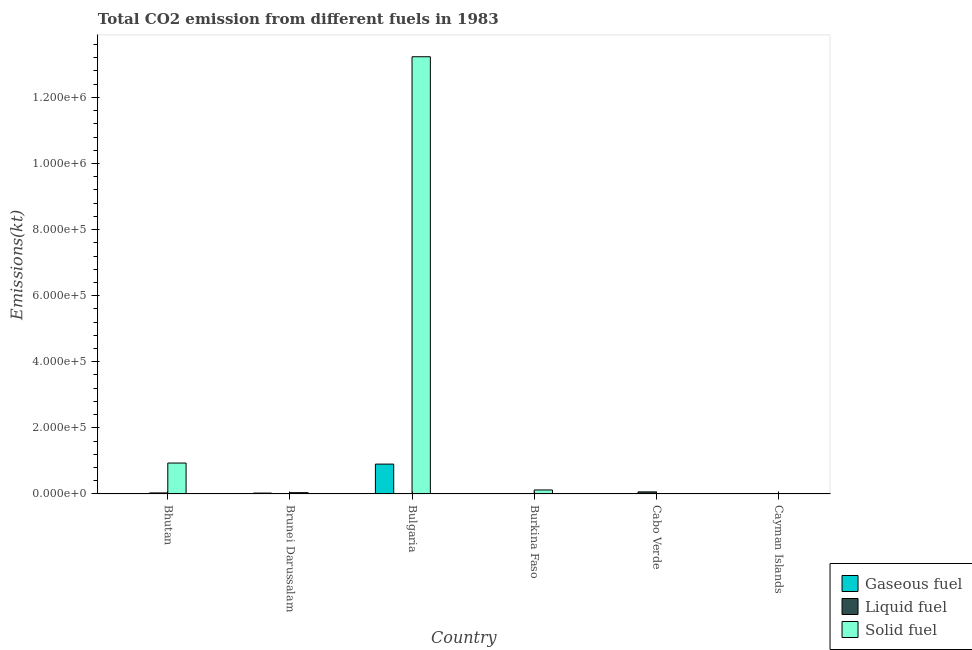How many different coloured bars are there?
Your answer should be compact. 3. Are the number of bars per tick equal to the number of legend labels?
Offer a very short reply. Yes. Are the number of bars on each tick of the X-axis equal?
Make the answer very short. Yes. How many bars are there on the 2nd tick from the left?
Ensure brevity in your answer.  3. What is the label of the 6th group of bars from the left?
Offer a terse response. Cayman Islands. In how many cases, is the number of bars for a given country not equal to the number of legend labels?
Make the answer very short. 0. What is the amount of co2 emissions from gaseous fuel in Burkina Faso?
Your response must be concise. 594.05. Across all countries, what is the maximum amount of co2 emissions from gaseous fuel?
Provide a short and direct response. 9.04e+04. Across all countries, what is the minimum amount of co2 emissions from solid fuel?
Provide a succinct answer. 238.35. In which country was the amount of co2 emissions from solid fuel maximum?
Keep it short and to the point. Bulgaria. In which country was the amount of co2 emissions from liquid fuel minimum?
Your answer should be very brief. Burkina Faso. What is the total amount of co2 emissions from solid fuel in the graph?
Make the answer very short. 1.43e+06. What is the difference between the amount of co2 emissions from solid fuel in Brunei Darussalam and that in Cabo Verde?
Ensure brevity in your answer.  3237.96. What is the difference between the amount of co2 emissions from solid fuel in Cayman Islands and the amount of co2 emissions from liquid fuel in Bulgaria?
Provide a succinct answer. 51.34. What is the average amount of co2 emissions from liquid fuel per country?
Provide a short and direct response. 1745.49. What is the difference between the amount of co2 emissions from gaseous fuel and amount of co2 emissions from liquid fuel in Bulgaria?
Provide a succinct answer. 9.02e+04. In how many countries, is the amount of co2 emissions from liquid fuel greater than 640000 kt?
Keep it short and to the point. 0. What is the ratio of the amount of co2 emissions from liquid fuel in Bhutan to that in Brunei Darussalam?
Give a very brief answer. 5.33. What is the difference between the highest and the second highest amount of co2 emissions from liquid fuel?
Give a very brief answer. 3113.28. What is the difference between the highest and the lowest amount of co2 emissions from liquid fuel?
Provide a succinct answer. 6244.9. Is the sum of the amount of co2 emissions from gaseous fuel in Cabo Verde and Cayman Islands greater than the maximum amount of co2 emissions from liquid fuel across all countries?
Provide a short and direct response. No. What does the 3rd bar from the left in Bulgaria represents?
Keep it short and to the point. Solid fuel. What does the 2nd bar from the right in Burkina Faso represents?
Make the answer very short. Liquid fuel. Is it the case that in every country, the sum of the amount of co2 emissions from gaseous fuel and amount of co2 emissions from liquid fuel is greater than the amount of co2 emissions from solid fuel?
Your answer should be compact. No. Are all the bars in the graph horizontal?
Keep it short and to the point. No. How many countries are there in the graph?
Make the answer very short. 6. What is the difference between two consecutive major ticks on the Y-axis?
Offer a terse response. 2.00e+05. Are the values on the major ticks of Y-axis written in scientific E-notation?
Offer a terse response. Yes. Does the graph contain any zero values?
Keep it short and to the point. No. Does the graph contain grids?
Offer a terse response. No. Where does the legend appear in the graph?
Your answer should be compact. Bottom right. What is the title of the graph?
Your response must be concise. Total CO2 emission from different fuels in 1983. What is the label or title of the X-axis?
Your response must be concise. Country. What is the label or title of the Y-axis?
Provide a short and direct response. Emissions(kt). What is the Emissions(kt) of Gaseous fuel in Bhutan?
Ensure brevity in your answer.  29.34. What is the Emissions(kt) of Liquid fuel in Bhutan?
Your answer should be very brief. 3168.29. What is the Emissions(kt) in Solid fuel in Bhutan?
Ensure brevity in your answer.  9.36e+04. What is the Emissions(kt) in Gaseous fuel in Brunei Darussalam?
Ensure brevity in your answer.  2706.25. What is the Emissions(kt) in Liquid fuel in Brunei Darussalam?
Provide a short and direct response. 594.05. What is the Emissions(kt) in Solid fuel in Brunei Darussalam?
Your answer should be very brief. 4044.7. What is the Emissions(kt) in Gaseous fuel in Bulgaria?
Offer a terse response. 9.04e+04. What is the Emissions(kt) of Liquid fuel in Bulgaria?
Your response must be concise. 187.02. What is the Emissions(kt) of Solid fuel in Bulgaria?
Offer a very short reply. 1.32e+06. What is the Emissions(kt) of Gaseous fuel in Burkina Faso?
Give a very brief answer. 594.05. What is the Emissions(kt) in Liquid fuel in Burkina Faso?
Give a very brief answer. 36.67. What is the Emissions(kt) of Solid fuel in Burkina Faso?
Your answer should be very brief. 1.21e+04. What is the Emissions(kt) of Gaseous fuel in Cabo Verde?
Your answer should be compact. 36.67. What is the Emissions(kt) in Liquid fuel in Cabo Verde?
Your answer should be compact. 6281.57. What is the Emissions(kt) in Solid fuel in Cabo Verde?
Provide a succinct answer. 806.74. What is the Emissions(kt) in Gaseous fuel in Cayman Islands?
Your response must be concise. 172.35. What is the Emissions(kt) in Liquid fuel in Cayman Islands?
Offer a very short reply. 205.35. What is the Emissions(kt) of Solid fuel in Cayman Islands?
Your answer should be compact. 238.35. Across all countries, what is the maximum Emissions(kt) in Gaseous fuel?
Ensure brevity in your answer.  9.04e+04. Across all countries, what is the maximum Emissions(kt) in Liquid fuel?
Your answer should be compact. 6281.57. Across all countries, what is the maximum Emissions(kt) in Solid fuel?
Provide a short and direct response. 1.32e+06. Across all countries, what is the minimum Emissions(kt) of Gaseous fuel?
Your answer should be compact. 29.34. Across all countries, what is the minimum Emissions(kt) of Liquid fuel?
Offer a very short reply. 36.67. Across all countries, what is the minimum Emissions(kt) in Solid fuel?
Ensure brevity in your answer.  238.35. What is the total Emissions(kt) in Gaseous fuel in the graph?
Offer a terse response. 9.39e+04. What is the total Emissions(kt) of Liquid fuel in the graph?
Provide a short and direct response. 1.05e+04. What is the total Emissions(kt) of Solid fuel in the graph?
Your answer should be compact. 1.43e+06. What is the difference between the Emissions(kt) in Gaseous fuel in Bhutan and that in Brunei Darussalam?
Ensure brevity in your answer.  -2676.91. What is the difference between the Emissions(kt) in Liquid fuel in Bhutan and that in Brunei Darussalam?
Your response must be concise. 2574.23. What is the difference between the Emissions(kt) in Solid fuel in Bhutan and that in Brunei Darussalam?
Give a very brief answer. 8.96e+04. What is the difference between the Emissions(kt) of Gaseous fuel in Bhutan and that in Bulgaria?
Provide a succinct answer. -9.03e+04. What is the difference between the Emissions(kt) in Liquid fuel in Bhutan and that in Bulgaria?
Offer a very short reply. 2981.27. What is the difference between the Emissions(kt) in Solid fuel in Bhutan and that in Bulgaria?
Provide a succinct answer. -1.23e+06. What is the difference between the Emissions(kt) in Gaseous fuel in Bhutan and that in Burkina Faso?
Make the answer very short. -564.72. What is the difference between the Emissions(kt) of Liquid fuel in Bhutan and that in Burkina Faso?
Your answer should be compact. 3131.62. What is the difference between the Emissions(kt) in Solid fuel in Bhutan and that in Burkina Faso?
Offer a terse response. 8.15e+04. What is the difference between the Emissions(kt) in Gaseous fuel in Bhutan and that in Cabo Verde?
Provide a short and direct response. -7.33. What is the difference between the Emissions(kt) in Liquid fuel in Bhutan and that in Cabo Verde?
Your answer should be very brief. -3113.28. What is the difference between the Emissions(kt) of Solid fuel in Bhutan and that in Cabo Verde?
Make the answer very short. 9.28e+04. What is the difference between the Emissions(kt) of Gaseous fuel in Bhutan and that in Cayman Islands?
Provide a succinct answer. -143.01. What is the difference between the Emissions(kt) of Liquid fuel in Bhutan and that in Cayman Islands?
Provide a short and direct response. 2962.94. What is the difference between the Emissions(kt) in Solid fuel in Bhutan and that in Cayman Islands?
Give a very brief answer. 9.34e+04. What is the difference between the Emissions(kt) in Gaseous fuel in Brunei Darussalam and that in Bulgaria?
Offer a very short reply. -8.77e+04. What is the difference between the Emissions(kt) in Liquid fuel in Brunei Darussalam and that in Bulgaria?
Give a very brief answer. 407.04. What is the difference between the Emissions(kt) of Solid fuel in Brunei Darussalam and that in Bulgaria?
Keep it short and to the point. -1.32e+06. What is the difference between the Emissions(kt) of Gaseous fuel in Brunei Darussalam and that in Burkina Faso?
Offer a terse response. 2112.19. What is the difference between the Emissions(kt) in Liquid fuel in Brunei Darussalam and that in Burkina Faso?
Offer a terse response. 557.38. What is the difference between the Emissions(kt) of Solid fuel in Brunei Darussalam and that in Burkina Faso?
Make the answer very short. -8104.07. What is the difference between the Emissions(kt) of Gaseous fuel in Brunei Darussalam and that in Cabo Verde?
Your answer should be very brief. 2669.58. What is the difference between the Emissions(kt) in Liquid fuel in Brunei Darussalam and that in Cabo Verde?
Your response must be concise. -5687.52. What is the difference between the Emissions(kt) in Solid fuel in Brunei Darussalam and that in Cabo Verde?
Keep it short and to the point. 3237.96. What is the difference between the Emissions(kt) of Gaseous fuel in Brunei Darussalam and that in Cayman Islands?
Your answer should be very brief. 2533.9. What is the difference between the Emissions(kt) of Liquid fuel in Brunei Darussalam and that in Cayman Islands?
Offer a terse response. 388.7. What is the difference between the Emissions(kt) in Solid fuel in Brunei Darussalam and that in Cayman Islands?
Your response must be concise. 3806.35. What is the difference between the Emissions(kt) of Gaseous fuel in Bulgaria and that in Burkina Faso?
Ensure brevity in your answer.  8.98e+04. What is the difference between the Emissions(kt) in Liquid fuel in Bulgaria and that in Burkina Faso?
Provide a succinct answer. 150.35. What is the difference between the Emissions(kt) of Solid fuel in Bulgaria and that in Burkina Faso?
Keep it short and to the point. 1.31e+06. What is the difference between the Emissions(kt) of Gaseous fuel in Bulgaria and that in Cabo Verde?
Ensure brevity in your answer.  9.03e+04. What is the difference between the Emissions(kt) of Liquid fuel in Bulgaria and that in Cabo Verde?
Offer a very short reply. -6094.55. What is the difference between the Emissions(kt) of Solid fuel in Bulgaria and that in Cabo Verde?
Offer a terse response. 1.32e+06. What is the difference between the Emissions(kt) of Gaseous fuel in Bulgaria and that in Cayman Islands?
Your answer should be very brief. 9.02e+04. What is the difference between the Emissions(kt) of Liquid fuel in Bulgaria and that in Cayman Islands?
Your response must be concise. -18.34. What is the difference between the Emissions(kt) of Solid fuel in Bulgaria and that in Cayman Islands?
Offer a terse response. 1.32e+06. What is the difference between the Emissions(kt) in Gaseous fuel in Burkina Faso and that in Cabo Verde?
Provide a succinct answer. 557.38. What is the difference between the Emissions(kt) in Liquid fuel in Burkina Faso and that in Cabo Verde?
Your response must be concise. -6244.9. What is the difference between the Emissions(kt) in Solid fuel in Burkina Faso and that in Cabo Verde?
Offer a terse response. 1.13e+04. What is the difference between the Emissions(kt) in Gaseous fuel in Burkina Faso and that in Cayman Islands?
Your response must be concise. 421.7. What is the difference between the Emissions(kt) in Liquid fuel in Burkina Faso and that in Cayman Islands?
Offer a terse response. -168.68. What is the difference between the Emissions(kt) of Solid fuel in Burkina Faso and that in Cayman Islands?
Your answer should be compact. 1.19e+04. What is the difference between the Emissions(kt) of Gaseous fuel in Cabo Verde and that in Cayman Islands?
Your answer should be very brief. -135.68. What is the difference between the Emissions(kt) in Liquid fuel in Cabo Verde and that in Cayman Islands?
Make the answer very short. 6076.22. What is the difference between the Emissions(kt) in Solid fuel in Cabo Verde and that in Cayman Islands?
Offer a very short reply. 568.38. What is the difference between the Emissions(kt) of Gaseous fuel in Bhutan and the Emissions(kt) of Liquid fuel in Brunei Darussalam?
Your answer should be compact. -564.72. What is the difference between the Emissions(kt) in Gaseous fuel in Bhutan and the Emissions(kt) in Solid fuel in Brunei Darussalam?
Keep it short and to the point. -4015.36. What is the difference between the Emissions(kt) of Liquid fuel in Bhutan and the Emissions(kt) of Solid fuel in Brunei Darussalam?
Offer a very short reply. -876.41. What is the difference between the Emissions(kt) of Gaseous fuel in Bhutan and the Emissions(kt) of Liquid fuel in Bulgaria?
Offer a very short reply. -157.68. What is the difference between the Emissions(kt) of Gaseous fuel in Bhutan and the Emissions(kt) of Solid fuel in Bulgaria?
Give a very brief answer. -1.32e+06. What is the difference between the Emissions(kt) of Liquid fuel in Bhutan and the Emissions(kt) of Solid fuel in Bulgaria?
Offer a very short reply. -1.32e+06. What is the difference between the Emissions(kt) of Gaseous fuel in Bhutan and the Emissions(kt) of Liquid fuel in Burkina Faso?
Give a very brief answer. -7.33. What is the difference between the Emissions(kt) in Gaseous fuel in Bhutan and the Emissions(kt) in Solid fuel in Burkina Faso?
Your answer should be very brief. -1.21e+04. What is the difference between the Emissions(kt) of Liquid fuel in Bhutan and the Emissions(kt) of Solid fuel in Burkina Faso?
Keep it short and to the point. -8980.48. What is the difference between the Emissions(kt) of Gaseous fuel in Bhutan and the Emissions(kt) of Liquid fuel in Cabo Verde?
Your answer should be compact. -6252.23. What is the difference between the Emissions(kt) of Gaseous fuel in Bhutan and the Emissions(kt) of Solid fuel in Cabo Verde?
Your answer should be very brief. -777.4. What is the difference between the Emissions(kt) of Liquid fuel in Bhutan and the Emissions(kt) of Solid fuel in Cabo Verde?
Give a very brief answer. 2361.55. What is the difference between the Emissions(kt) of Gaseous fuel in Bhutan and the Emissions(kt) of Liquid fuel in Cayman Islands?
Your answer should be very brief. -176.02. What is the difference between the Emissions(kt) in Gaseous fuel in Bhutan and the Emissions(kt) in Solid fuel in Cayman Islands?
Make the answer very short. -209.02. What is the difference between the Emissions(kt) of Liquid fuel in Bhutan and the Emissions(kt) of Solid fuel in Cayman Islands?
Give a very brief answer. 2929.93. What is the difference between the Emissions(kt) of Gaseous fuel in Brunei Darussalam and the Emissions(kt) of Liquid fuel in Bulgaria?
Give a very brief answer. 2519.23. What is the difference between the Emissions(kt) of Gaseous fuel in Brunei Darussalam and the Emissions(kt) of Solid fuel in Bulgaria?
Ensure brevity in your answer.  -1.32e+06. What is the difference between the Emissions(kt) of Liquid fuel in Brunei Darussalam and the Emissions(kt) of Solid fuel in Bulgaria?
Your answer should be very brief. -1.32e+06. What is the difference between the Emissions(kt) of Gaseous fuel in Brunei Darussalam and the Emissions(kt) of Liquid fuel in Burkina Faso?
Provide a short and direct response. 2669.58. What is the difference between the Emissions(kt) in Gaseous fuel in Brunei Darussalam and the Emissions(kt) in Solid fuel in Burkina Faso?
Offer a very short reply. -9442.52. What is the difference between the Emissions(kt) in Liquid fuel in Brunei Darussalam and the Emissions(kt) in Solid fuel in Burkina Faso?
Ensure brevity in your answer.  -1.16e+04. What is the difference between the Emissions(kt) of Gaseous fuel in Brunei Darussalam and the Emissions(kt) of Liquid fuel in Cabo Verde?
Provide a short and direct response. -3575.32. What is the difference between the Emissions(kt) in Gaseous fuel in Brunei Darussalam and the Emissions(kt) in Solid fuel in Cabo Verde?
Your response must be concise. 1899.51. What is the difference between the Emissions(kt) in Liquid fuel in Brunei Darussalam and the Emissions(kt) in Solid fuel in Cabo Verde?
Your answer should be very brief. -212.69. What is the difference between the Emissions(kt) in Gaseous fuel in Brunei Darussalam and the Emissions(kt) in Liquid fuel in Cayman Islands?
Ensure brevity in your answer.  2500.89. What is the difference between the Emissions(kt) in Gaseous fuel in Brunei Darussalam and the Emissions(kt) in Solid fuel in Cayman Islands?
Your answer should be compact. 2467.89. What is the difference between the Emissions(kt) in Liquid fuel in Brunei Darussalam and the Emissions(kt) in Solid fuel in Cayman Islands?
Provide a short and direct response. 355.7. What is the difference between the Emissions(kt) in Gaseous fuel in Bulgaria and the Emissions(kt) in Liquid fuel in Burkina Faso?
Your answer should be compact. 9.03e+04. What is the difference between the Emissions(kt) in Gaseous fuel in Bulgaria and the Emissions(kt) in Solid fuel in Burkina Faso?
Make the answer very short. 7.82e+04. What is the difference between the Emissions(kt) of Liquid fuel in Bulgaria and the Emissions(kt) of Solid fuel in Burkina Faso?
Offer a very short reply. -1.20e+04. What is the difference between the Emissions(kt) in Gaseous fuel in Bulgaria and the Emissions(kt) in Liquid fuel in Cabo Verde?
Your answer should be very brief. 8.41e+04. What is the difference between the Emissions(kt) of Gaseous fuel in Bulgaria and the Emissions(kt) of Solid fuel in Cabo Verde?
Make the answer very short. 8.96e+04. What is the difference between the Emissions(kt) of Liquid fuel in Bulgaria and the Emissions(kt) of Solid fuel in Cabo Verde?
Ensure brevity in your answer.  -619.72. What is the difference between the Emissions(kt) in Gaseous fuel in Bulgaria and the Emissions(kt) in Liquid fuel in Cayman Islands?
Your answer should be very brief. 9.02e+04. What is the difference between the Emissions(kt) of Gaseous fuel in Bulgaria and the Emissions(kt) of Solid fuel in Cayman Islands?
Your response must be concise. 9.01e+04. What is the difference between the Emissions(kt) of Liquid fuel in Bulgaria and the Emissions(kt) of Solid fuel in Cayman Islands?
Offer a terse response. -51.34. What is the difference between the Emissions(kt) in Gaseous fuel in Burkina Faso and the Emissions(kt) in Liquid fuel in Cabo Verde?
Give a very brief answer. -5687.52. What is the difference between the Emissions(kt) of Gaseous fuel in Burkina Faso and the Emissions(kt) of Solid fuel in Cabo Verde?
Offer a terse response. -212.69. What is the difference between the Emissions(kt) of Liquid fuel in Burkina Faso and the Emissions(kt) of Solid fuel in Cabo Verde?
Your response must be concise. -770.07. What is the difference between the Emissions(kt) in Gaseous fuel in Burkina Faso and the Emissions(kt) in Liquid fuel in Cayman Islands?
Offer a very short reply. 388.7. What is the difference between the Emissions(kt) of Gaseous fuel in Burkina Faso and the Emissions(kt) of Solid fuel in Cayman Islands?
Your answer should be compact. 355.7. What is the difference between the Emissions(kt) of Liquid fuel in Burkina Faso and the Emissions(kt) of Solid fuel in Cayman Islands?
Offer a terse response. -201.69. What is the difference between the Emissions(kt) of Gaseous fuel in Cabo Verde and the Emissions(kt) of Liquid fuel in Cayman Islands?
Provide a succinct answer. -168.68. What is the difference between the Emissions(kt) of Gaseous fuel in Cabo Verde and the Emissions(kt) of Solid fuel in Cayman Islands?
Ensure brevity in your answer.  -201.69. What is the difference between the Emissions(kt) of Liquid fuel in Cabo Verde and the Emissions(kt) of Solid fuel in Cayman Islands?
Provide a short and direct response. 6043.22. What is the average Emissions(kt) in Gaseous fuel per country?
Your answer should be very brief. 1.57e+04. What is the average Emissions(kt) of Liquid fuel per country?
Your answer should be compact. 1745.49. What is the average Emissions(kt) in Solid fuel per country?
Your response must be concise. 2.39e+05. What is the difference between the Emissions(kt) of Gaseous fuel and Emissions(kt) of Liquid fuel in Bhutan?
Keep it short and to the point. -3138.95. What is the difference between the Emissions(kt) in Gaseous fuel and Emissions(kt) in Solid fuel in Bhutan?
Keep it short and to the point. -9.36e+04. What is the difference between the Emissions(kt) of Liquid fuel and Emissions(kt) of Solid fuel in Bhutan?
Your answer should be compact. -9.04e+04. What is the difference between the Emissions(kt) in Gaseous fuel and Emissions(kt) in Liquid fuel in Brunei Darussalam?
Keep it short and to the point. 2112.19. What is the difference between the Emissions(kt) in Gaseous fuel and Emissions(kt) in Solid fuel in Brunei Darussalam?
Offer a very short reply. -1338.45. What is the difference between the Emissions(kt) of Liquid fuel and Emissions(kt) of Solid fuel in Brunei Darussalam?
Offer a very short reply. -3450.65. What is the difference between the Emissions(kt) in Gaseous fuel and Emissions(kt) in Liquid fuel in Bulgaria?
Offer a terse response. 9.02e+04. What is the difference between the Emissions(kt) in Gaseous fuel and Emissions(kt) in Solid fuel in Bulgaria?
Your answer should be very brief. -1.23e+06. What is the difference between the Emissions(kt) in Liquid fuel and Emissions(kt) in Solid fuel in Bulgaria?
Provide a succinct answer. -1.32e+06. What is the difference between the Emissions(kt) in Gaseous fuel and Emissions(kt) in Liquid fuel in Burkina Faso?
Give a very brief answer. 557.38. What is the difference between the Emissions(kt) of Gaseous fuel and Emissions(kt) of Solid fuel in Burkina Faso?
Your answer should be compact. -1.16e+04. What is the difference between the Emissions(kt) in Liquid fuel and Emissions(kt) in Solid fuel in Burkina Faso?
Offer a terse response. -1.21e+04. What is the difference between the Emissions(kt) in Gaseous fuel and Emissions(kt) in Liquid fuel in Cabo Verde?
Your answer should be compact. -6244.9. What is the difference between the Emissions(kt) of Gaseous fuel and Emissions(kt) of Solid fuel in Cabo Verde?
Make the answer very short. -770.07. What is the difference between the Emissions(kt) in Liquid fuel and Emissions(kt) in Solid fuel in Cabo Verde?
Keep it short and to the point. 5474.83. What is the difference between the Emissions(kt) in Gaseous fuel and Emissions(kt) in Liquid fuel in Cayman Islands?
Provide a succinct answer. -33. What is the difference between the Emissions(kt) of Gaseous fuel and Emissions(kt) of Solid fuel in Cayman Islands?
Keep it short and to the point. -66.01. What is the difference between the Emissions(kt) in Liquid fuel and Emissions(kt) in Solid fuel in Cayman Islands?
Ensure brevity in your answer.  -33. What is the ratio of the Emissions(kt) of Gaseous fuel in Bhutan to that in Brunei Darussalam?
Provide a short and direct response. 0.01. What is the ratio of the Emissions(kt) of Liquid fuel in Bhutan to that in Brunei Darussalam?
Give a very brief answer. 5.33. What is the ratio of the Emissions(kt) of Solid fuel in Bhutan to that in Brunei Darussalam?
Your answer should be compact. 23.14. What is the ratio of the Emissions(kt) in Liquid fuel in Bhutan to that in Bulgaria?
Ensure brevity in your answer.  16.94. What is the ratio of the Emissions(kt) in Solid fuel in Bhutan to that in Bulgaria?
Give a very brief answer. 0.07. What is the ratio of the Emissions(kt) of Gaseous fuel in Bhutan to that in Burkina Faso?
Keep it short and to the point. 0.05. What is the ratio of the Emissions(kt) in Liquid fuel in Bhutan to that in Burkina Faso?
Give a very brief answer. 86.4. What is the ratio of the Emissions(kt) of Solid fuel in Bhutan to that in Burkina Faso?
Give a very brief answer. 7.7. What is the ratio of the Emissions(kt) of Gaseous fuel in Bhutan to that in Cabo Verde?
Provide a short and direct response. 0.8. What is the ratio of the Emissions(kt) in Liquid fuel in Bhutan to that in Cabo Verde?
Provide a short and direct response. 0.5. What is the ratio of the Emissions(kt) in Solid fuel in Bhutan to that in Cabo Verde?
Your response must be concise. 116.02. What is the ratio of the Emissions(kt) in Gaseous fuel in Bhutan to that in Cayman Islands?
Your response must be concise. 0.17. What is the ratio of the Emissions(kt) of Liquid fuel in Bhutan to that in Cayman Islands?
Make the answer very short. 15.43. What is the ratio of the Emissions(kt) in Solid fuel in Bhutan to that in Cayman Islands?
Keep it short and to the point. 392.69. What is the ratio of the Emissions(kt) of Gaseous fuel in Brunei Darussalam to that in Bulgaria?
Your answer should be very brief. 0.03. What is the ratio of the Emissions(kt) of Liquid fuel in Brunei Darussalam to that in Bulgaria?
Ensure brevity in your answer.  3.18. What is the ratio of the Emissions(kt) of Solid fuel in Brunei Darussalam to that in Bulgaria?
Your response must be concise. 0. What is the ratio of the Emissions(kt) in Gaseous fuel in Brunei Darussalam to that in Burkina Faso?
Your answer should be compact. 4.56. What is the ratio of the Emissions(kt) of Solid fuel in Brunei Darussalam to that in Burkina Faso?
Your answer should be very brief. 0.33. What is the ratio of the Emissions(kt) in Gaseous fuel in Brunei Darussalam to that in Cabo Verde?
Your answer should be compact. 73.8. What is the ratio of the Emissions(kt) in Liquid fuel in Brunei Darussalam to that in Cabo Verde?
Offer a very short reply. 0.09. What is the ratio of the Emissions(kt) in Solid fuel in Brunei Darussalam to that in Cabo Verde?
Your answer should be very brief. 5.01. What is the ratio of the Emissions(kt) of Gaseous fuel in Brunei Darussalam to that in Cayman Islands?
Your answer should be compact. 15.7. What is the ratio of the Emissions(kt) in Liquid fuel in Brunei Darussalam to that in Cayman Islands?
Ensure brevity in your answer.  2.89. What is the ratio of the Emissions(kt) in Solid fuel in Brunei Darussalam to that in Cayman Islands?
Ensure brevity in your answer.  16.97. What is the ratio of the Emissions(kt) of Gaseous fuel in Bulgaria to that in Burkina Faso?
Give a very brief answer. 152.12. What is the ratio of the Emissions(kt) in Liquid fuel in Bulgaria to that in Burkina Faso?
Offer a terse response. 5.1. What is the ratio of the Emissions(kt) of Solid fuel in Bulgaria to that in Burkina Faso?
Ensure brevity in your answer.  108.89. What is the ratio of the Emissions(kt) in Gaseous fuel in Bulgaria to that in Cabo Verde?
Provide a short and direct response. 2464.3. What is the ratio of the Emissions(kt) in Liquid fuel in Bulgaria to that in Cabo Verde?
Make the answer very short. 0.03. What is the ratio of the Emissions(kt) of Solid fuel in Bulgaria to that in Cabo Verde?
Offer a terse response. 1639.84. What is the ratio of the Emissions(kt) in Gaseous fuel in Bulgaria to that in Cayman Islands?
Offer a terse response. 524.32. What is the ratio of the Emissions(kt) of Liquid fuel in Bulgaria to that in Cayman Islands?
Your response must be concise. 0.91. What is the ratio of the Emissions(kt) of Solid fuel in Bulgaria to that in Cayman Islands?
Keep it short and to the point. 5550.23. What is the ratio of the Emissions(kt) of Liquid fuel in Burkina Faso to that in Cabo Verde?
Give a very brief answer. 0.01. What is the ratio of the Emissions(kt) of Solid fuel in Burkina Faso to that in Cabo Verde?
Offer a very short reply. 15.06. What is the ratio of the Emissions(kt) in Gaseous fuel in Burkina Faso to that in Cayman Islands?
Provide a succinct answer. 3.45. What is the ratio of the Emissions(kt) in Liquid fuel in Burkina Faso to that in Cayman Islands?
Your answer should be compact. 0.18. What is the ratio of the Emissions(kt) of Solid fuel in Burkina Faso to that in Cayman Islands?
Your answer should be very brief. 50.97. What is the ratio of the Emissions(kt) of Gaseous fuel in Cabo Verde to that in Cayman Islands?
Keep it short and to the point. 0.21. What is the ratio of the Emissions(kt) of Liquid fuel in Cabo Verde to that in Cayman Islands?
Keep it short and to the point. 30.59. What is the ratio of the Emissions(kt) in Solid fuel in Cabo Verde to that in Cayman Islands?
Keep it short and to the point. 3.38. What is the difference between the highest and the second highest Emissions(kt) of Gaseous fuel?
Provide a succinct answer. 8.77e+04. What is the difference between the highest and the second highest Emissions(kt) of Liquid fuel?
Provide a short and direct response. 3113.28. What is the difference between the highest and the second highest Emissions(kt) of Solid fuel?
Provide a succinct answer. 1.23e+06. What is the difference between the highest and the lowest Emissions(kt) in Gaseous fuel?
Give a very brief answer. 9.03e+04. What is the difference between the highest and the lowest Emissions(kt) in Liquid fuel?
Your response must be concise. 6244.9. What is the difference between the highest and the lowest Emissions(kt) of Solid fuel?
Provide a short and direct response. 1.32e+06. 